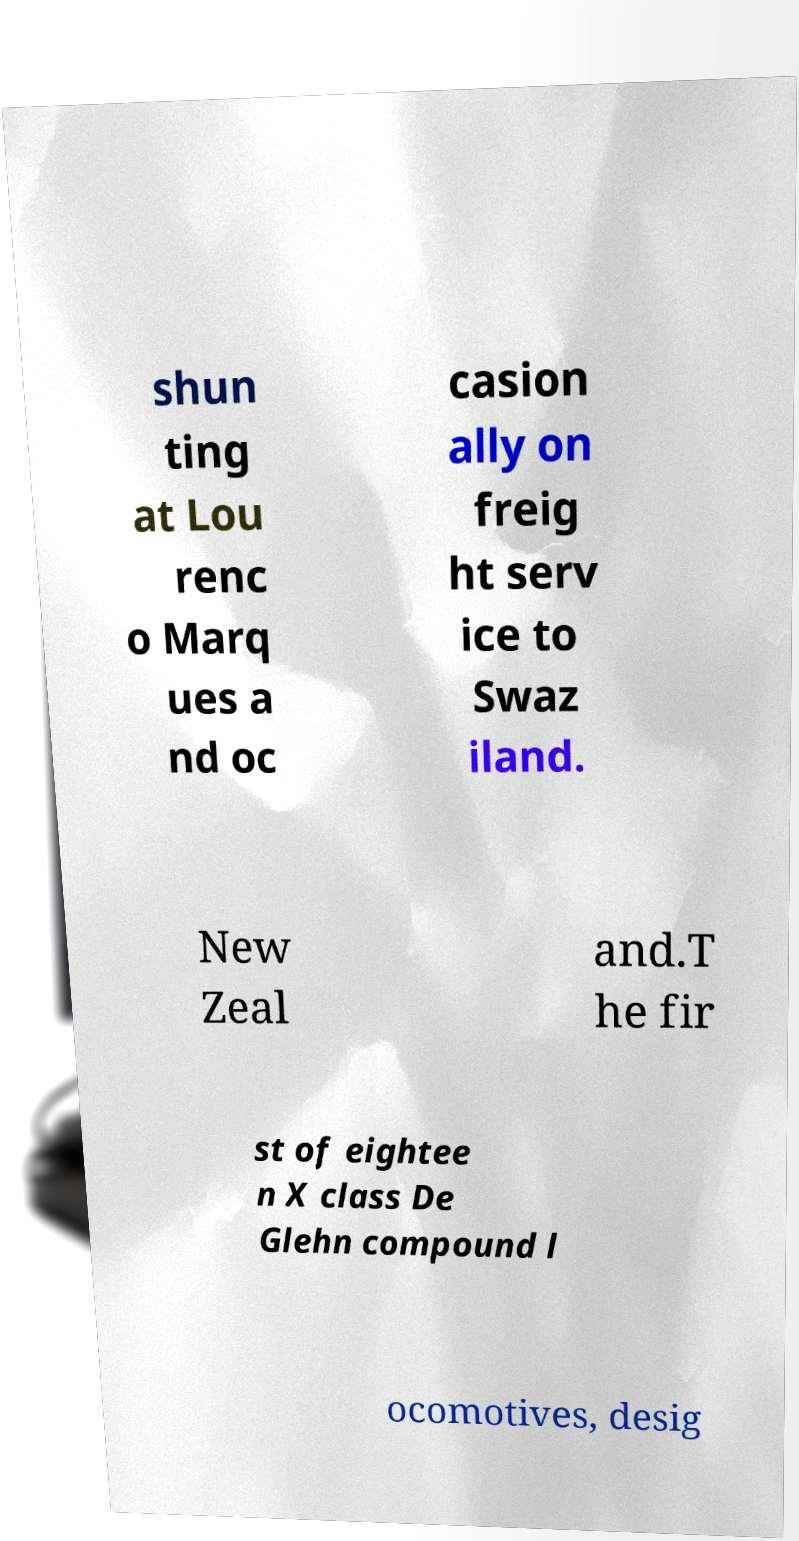Can you accurately transcribe the text from the provided image for me? shun ting at Lou renc o Marq ues a nd oc casion ally on freig ht serv ice to Swaz iland. New Zeal and.T he fir st of eightee n X class De Glehn compound l ocomotives, desig 